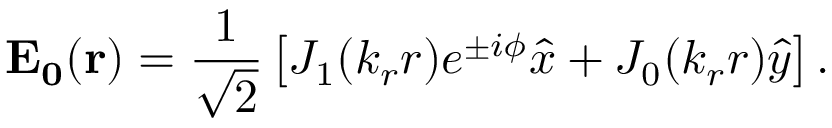<formula> <loc_0><loc_0><loc_500><loc_500>E _ { 0 } ( \mathbf { r } ) = \frac { 1 } { \sqrt { 2 } } \left [ J _ { 1 } ( k _ { r } r ) e ^ { \pm i \phi } \hat { x } + J _ { 0 } ( k _ { r } r ) \hat { y } \right ] .</formula> 